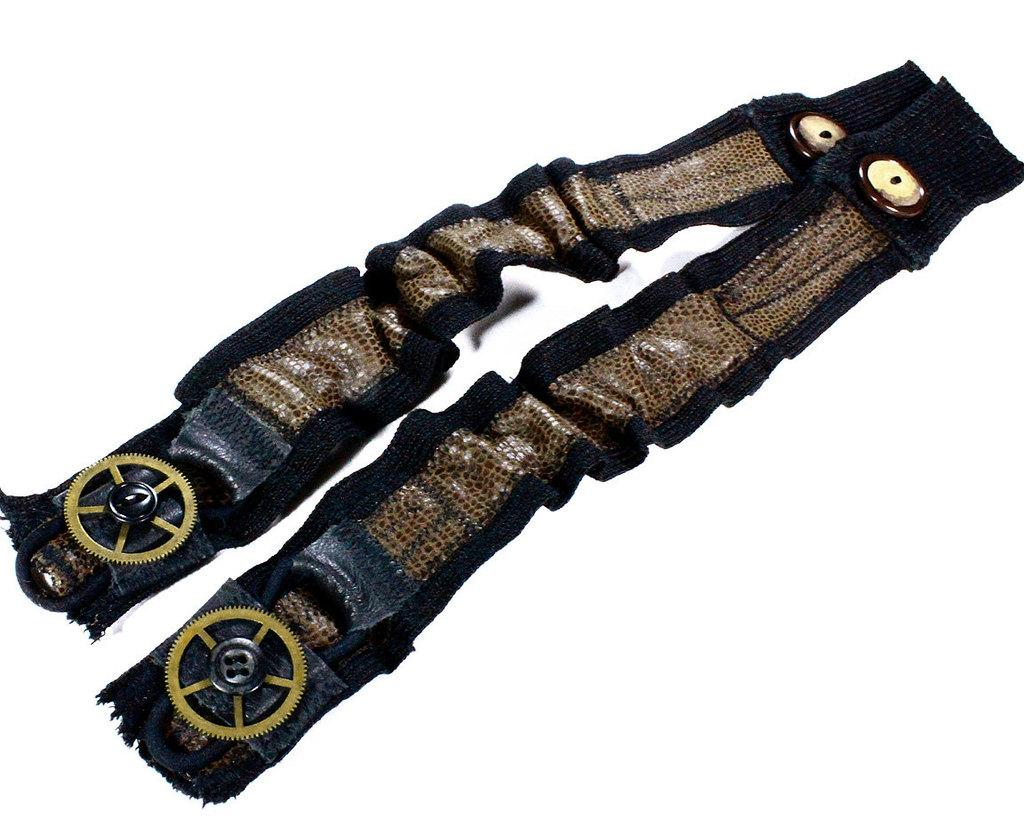What type of material is used for the straps in the image? The straps in the image are made of leather. What additional features can be seen on the leather straps? There are buttons and wheels on the leather straps. Are there any other objects attached to the leather straps? Yes, there are other objects on the leather straps. What color is the background of the image? The background of the image is white. How does the cap affect the range of the steam in the image? There is no cap or steam present in the image; it features leather straps with buttons, wheels, and other objects. 